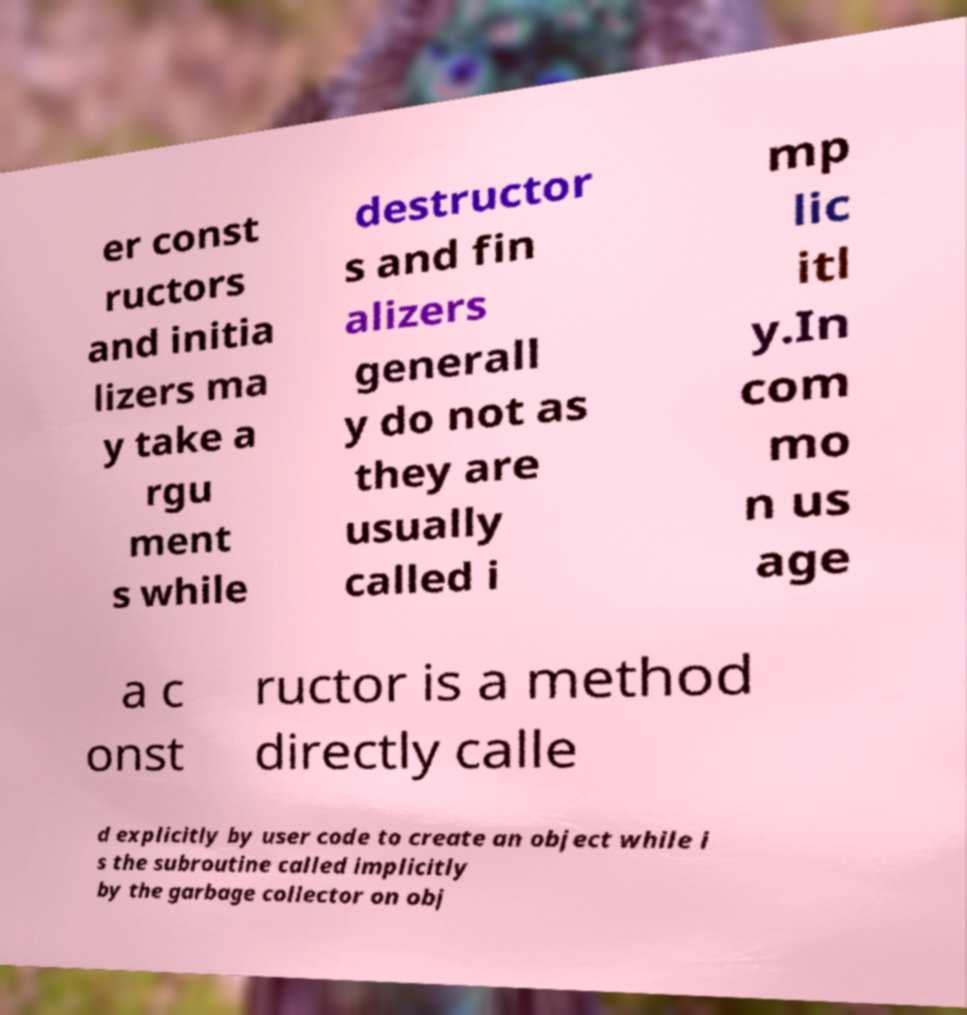Please identify and transcribe the text found in this image. er const ructors and initia lizers ma y take a rgu ment s while destructor s and fin alizers generall y do not as they are usually called i mp lic itl y.In com mo n us age a c onst ructor is a method directly calle d explicitly by user code to create an object while i s the subroutine called implicitly by the garbage collector on obj 